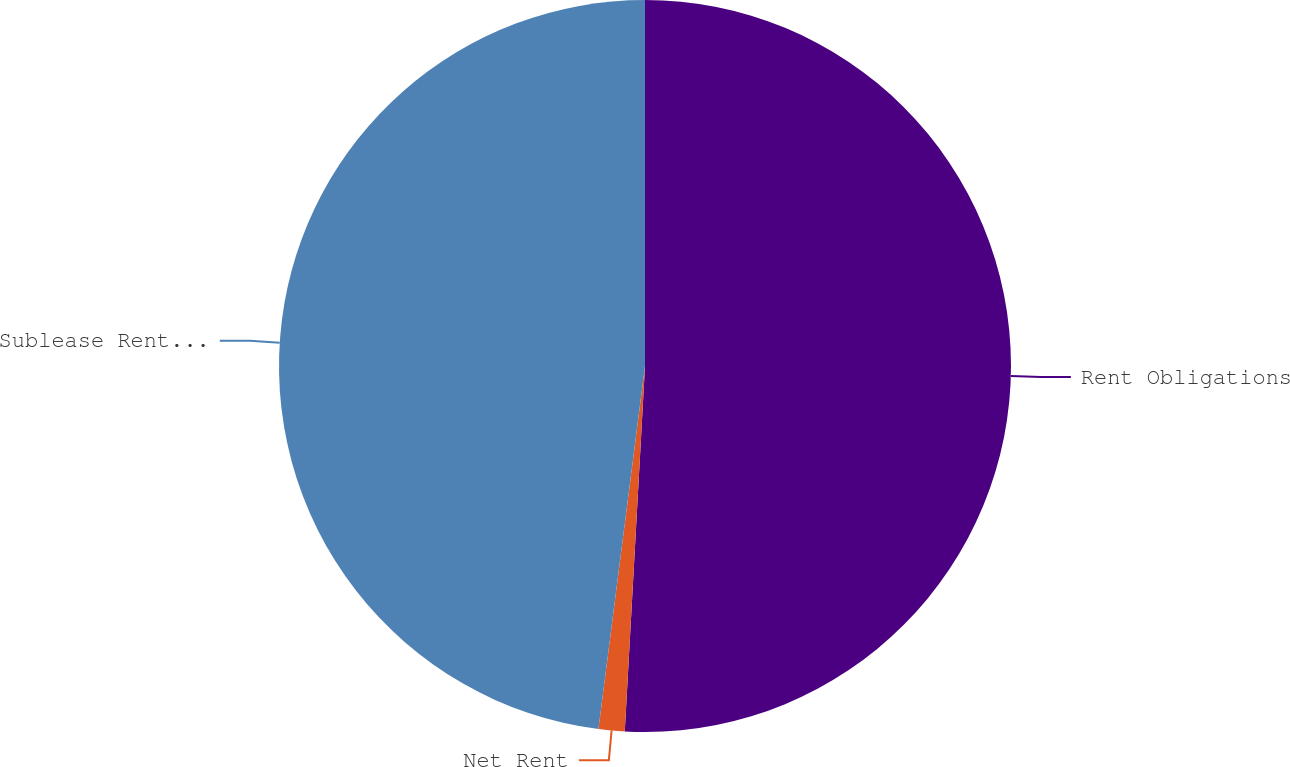Convert chart. <chart><loc_0><loc_0><loc_500><loc_500><pie_chart><fcel>Rent Obligations<fcel>Net Rent<fcel>Sublease Rental Income<nl><fcel>50.88%<fcel>1.15%<fcel>47.97%<nl></chart> 